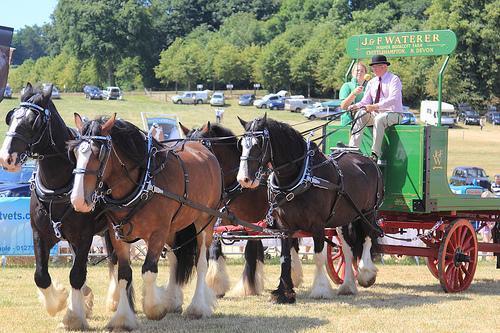How many horses are there?
Give a very brief answer. 4. How many people are riding in the wagon?
Give a very brief answer. 2. 